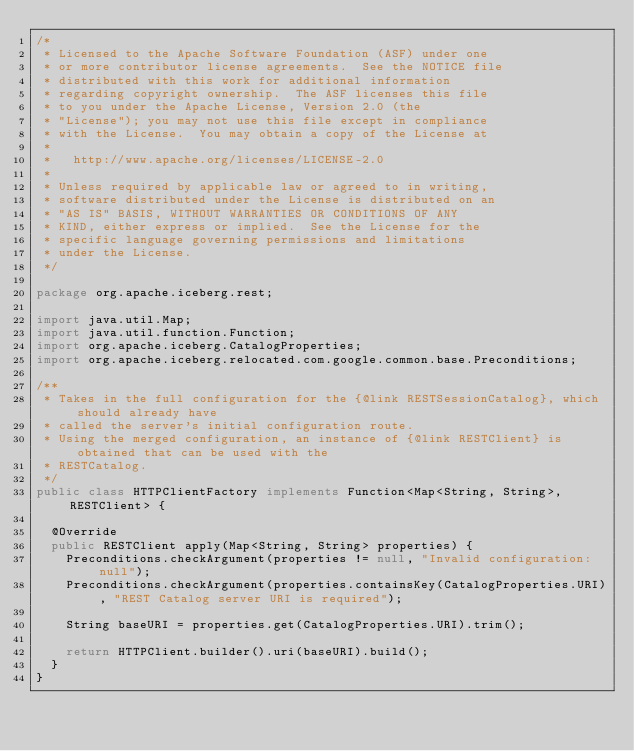<code> <loc_0><loc_0><loc_500><loc_500><_Java_>/*
 * Licensed to the Apache Software Foundation (ASF) under one
 * or more contributor license agreements.  See the NOTICE file
 * distributed with this work for additional information
 * regarding copyright ownership.  The ASF licenses this file
 * to you under the Apache License, Version 2.0 (the
 * "License"); you may not use this file except in compliance
 * with the License.  You may obtain a copy of the License at
 *
 *   http://www.apache.org/licenses/LICENSE-2.0
 *
 * Unless required by applicable law or agreed to in writing,
 * software distributed under the License is distributed on an
 * "AS IS" BASIS, WITHOUT WARRANTIES OR CONDITIONS OF ANY
 * KIND, either express or implied.  See the License for the
 * specific language governing permissions and limitations
 * under the License.
 */

package org.apache.iceberg.rest;

import java.util.Map;
import java.util.function.Function;
import org.apache.iceberg.CatalogProperties;
import org.apache.iceberg.relocated.com.google.common.base.Preconditions;

/**
 * Takes in the full configuration for the {@link RESTSessionCatalog}, which should already have
 * called the server's initial configuration route.
 * Using the merged configuration, an instance of {@link RESTClient} is obtained that can be used with the
 * RESTCatalog.
 */
public class HTTPClientFactory implements Function<Map<String, String>, RESTClient> {

  @Override
  public RESTClient apply(Map<String, String> properties) {
    Preconditions.checkArgument(properties != null, "Invalid configuration: null");
    Preconditions.checkArgument(properties.containsKey(CatalogProperties.URI), "REST Catalog server URI is required");

    String baseURI = properties.get(CatalogProperties.URI).trim();

    return HTTPClient.builder().uri(baseURI).build();
  }
}
</code> 